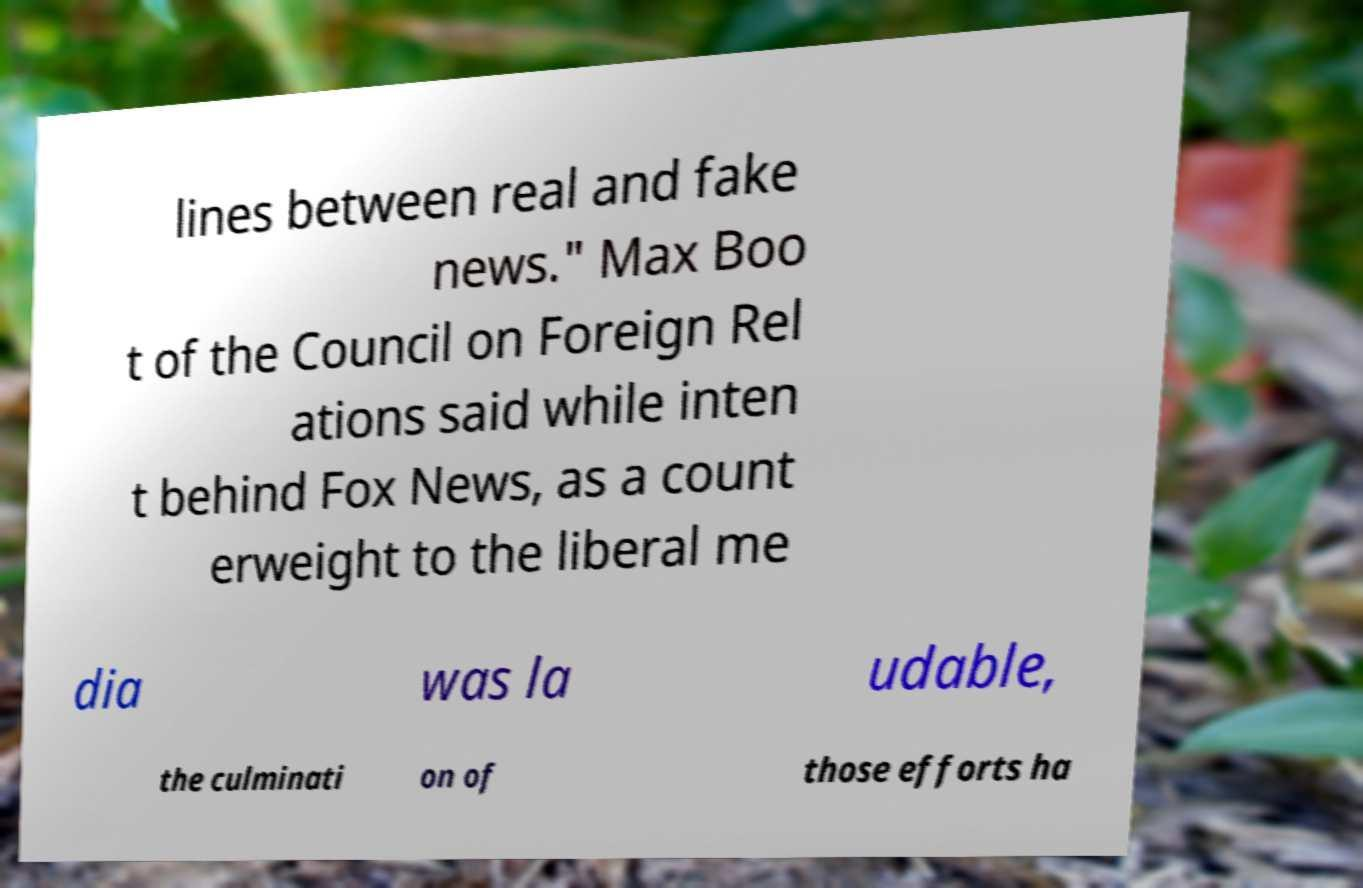Could you assist in decoding the text presented in this image and type it out clearly? lines between real and fake news." Max Boo t of the Council on Foreign Rel ations said while inten t behind Fox News, as a count erweight to the liberal me dia was la udable, the culminati on of those efforts ha 